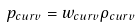Convert formula to latex. <formula><loc_0><loc_0><loc_500><loc_500>p _ { c u r v } = w _ { c u r v } \rho _ { c u r v }</formula> 